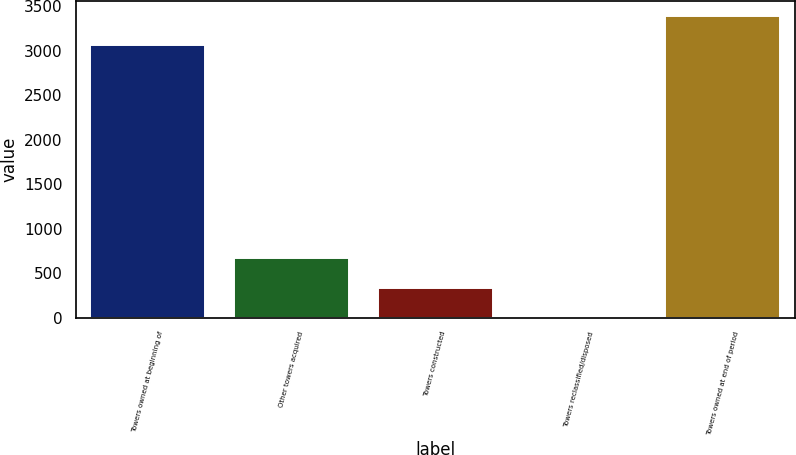Convert chart. <chart><loc_0><loc_0><loc_500><loc_500><bar_chart><fcel>Towers owned at beginning of<fcel>Other towers acquired<fcel>Towers constructed<fcel>Towers reclassified/disposed<fcel>Towers owned at end of period<nl><fcel>3066<fcel>665.6<fcel>335.8<fcel>6<fcel>3395.8<nl></chart> 